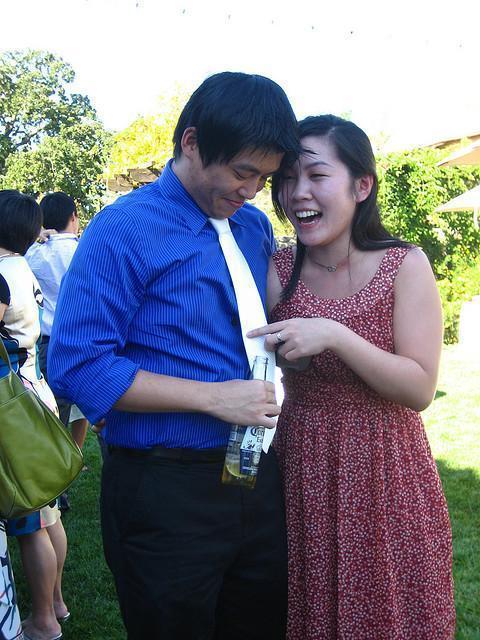How are the two people related?
Answer the question by selecting the correct answer among the 4 following choices and explain your choice with a short sentence. The answer should be formatted with the following format: `Answer: choice
Rationale: rationale.`
Options: Coworkers, classmates, lovers, siblings. Answer: lovers.
Rationale: The couple are embracing each other affectionately. 